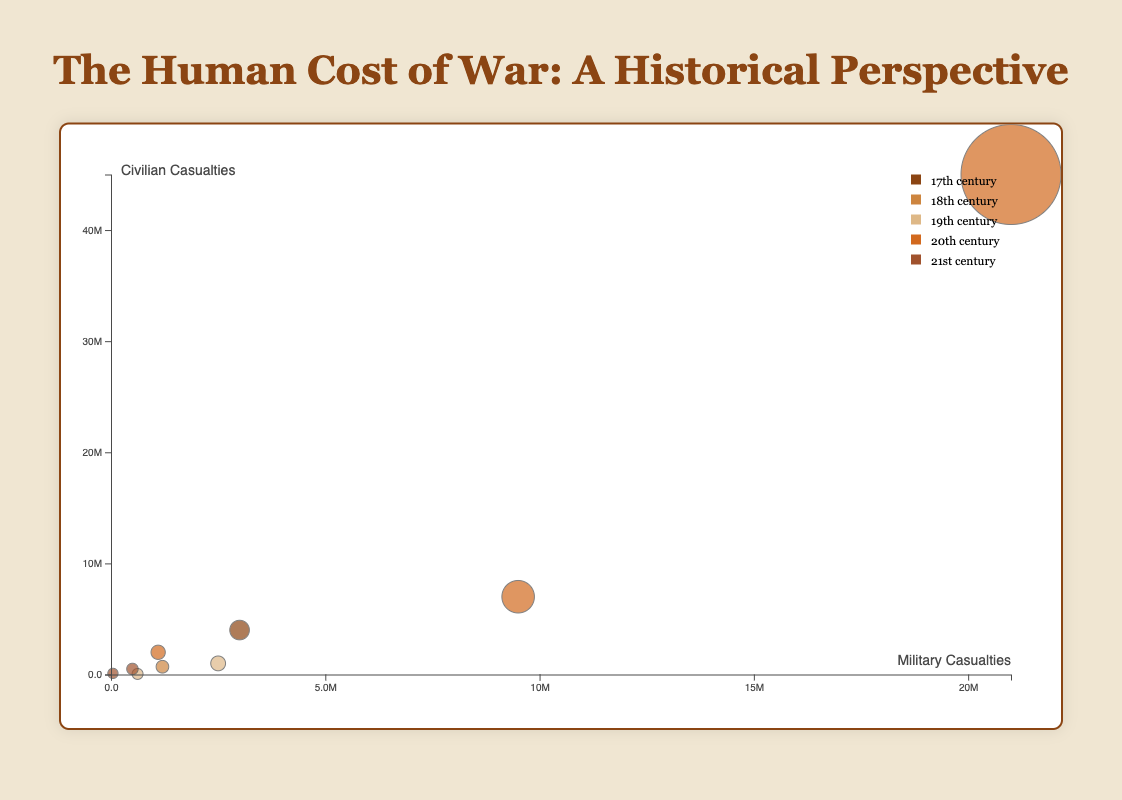What is the title of the chart? The title is usually displayed on top of the chart. It reads "The Human Cost of War: A Historical Perspective."
Answer: The Human Cost of War: A Historical Perspective Which century had the highest number of military casualties? Look at the horizontal (x) axis to identify the bubble furthest to the right, representing the highest military casualties. The bubble for World War II, in the 20th century, is furthest to the right.
Answer: 20th How many wars are depicted in the 19th century? Look for the color corresponding to the 19th century in the legend and count the bubbles of that color. There are two bubbles: Napoleonic Wars and American Civil War.
Answer: 2 Which war had the smallest overall casualties? Identify the smallest bubble in size. The Iraq War bubble is the smallest, indicating it has the smallest overall casualties.
Answer: Iraq War Are there more military or civilian casualties represented in the Thirty Years' War? Refer to the tooltip information for the Thirty Years' War bubble. It shows military casualties of 3,000,000 and civilian casualties of 4,000,000.
Answer: Civilian casualties What is the sum of civilian casualties for the wars in the 21st century? The 21st-century wars shown are the Iraq War (100,000 civilian casualties) and the Syrian Civil War (500,000 civilian casualties). Sum them: 100,000 + 500,000 = 600,000.
Answer: 600,000 Which war in the 20th century has more civilian casualties, World War I or Vietnam War? Find the bubbles for World War I and Vietnam War and compare the vertical (y) values. World War I has 7,000,000 civilian casualties, while Vietnam War has 2,000,000.
Answer: World War I Which century saw the highest total number of civilian casualties? Look at each century's bubbles and sum their civilian casualties. The 20th century has:
World War I: 7,000,000
World War II: 45,000,000
Vietnam War: 2,000,000
Total: 54,000,000
Answer: 20th century Is there any war where military and civilian casualties are equal? Check the bubbles' tooltips to compare numbers. In the Syrian Civil War bubble, both casualties are 500,000.
Answer: Syrian Civil War What do the sizes of the bubbles represent in this chart? The size of each bubble indicates the total number of casualties (military + civilian) for that war. A larger bubble means more overall casualties.
Answer: Total number of casualties 